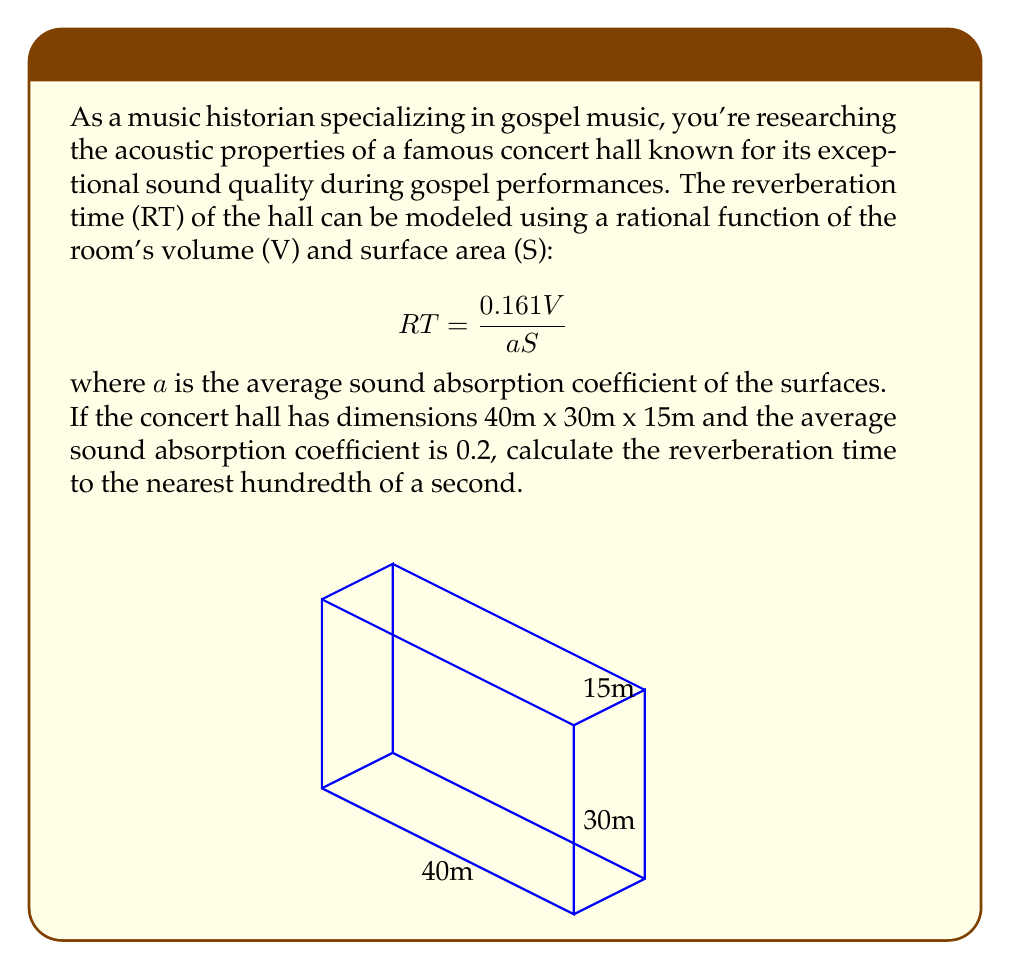Can you solve this math problem? Let's approach this step-by-step:

1) First, we need to calculate the volume (V) of the concert hall:
   $$V = 40m \times 30m \times 15m = 18,000 \text{ m}^3$$

2) Next, we need to calculate the surface area (S) of the hall:
   $$S = 2(40 \times 30 + 40 \times 15 + 30 \times 15) = 3,900 \text{ m}^2$$

3) We're given that the average sound absorption coefficient (a) is 0.2.

4) Now we can plug these values into our rational function:
   $$RT = \frac{0.161V}{aS} = \frac{0.161 \times 18,000}{0.2 \times 3,900}$$

5) Let's calculate:
   $$RT = \frac{2,898}{780} = 3.715384615...$$

6) Rounding to the nearest hundredth:
   $$RT \approx 3.72 \text{ seconds}$$
Answer: 3.72 seconds 